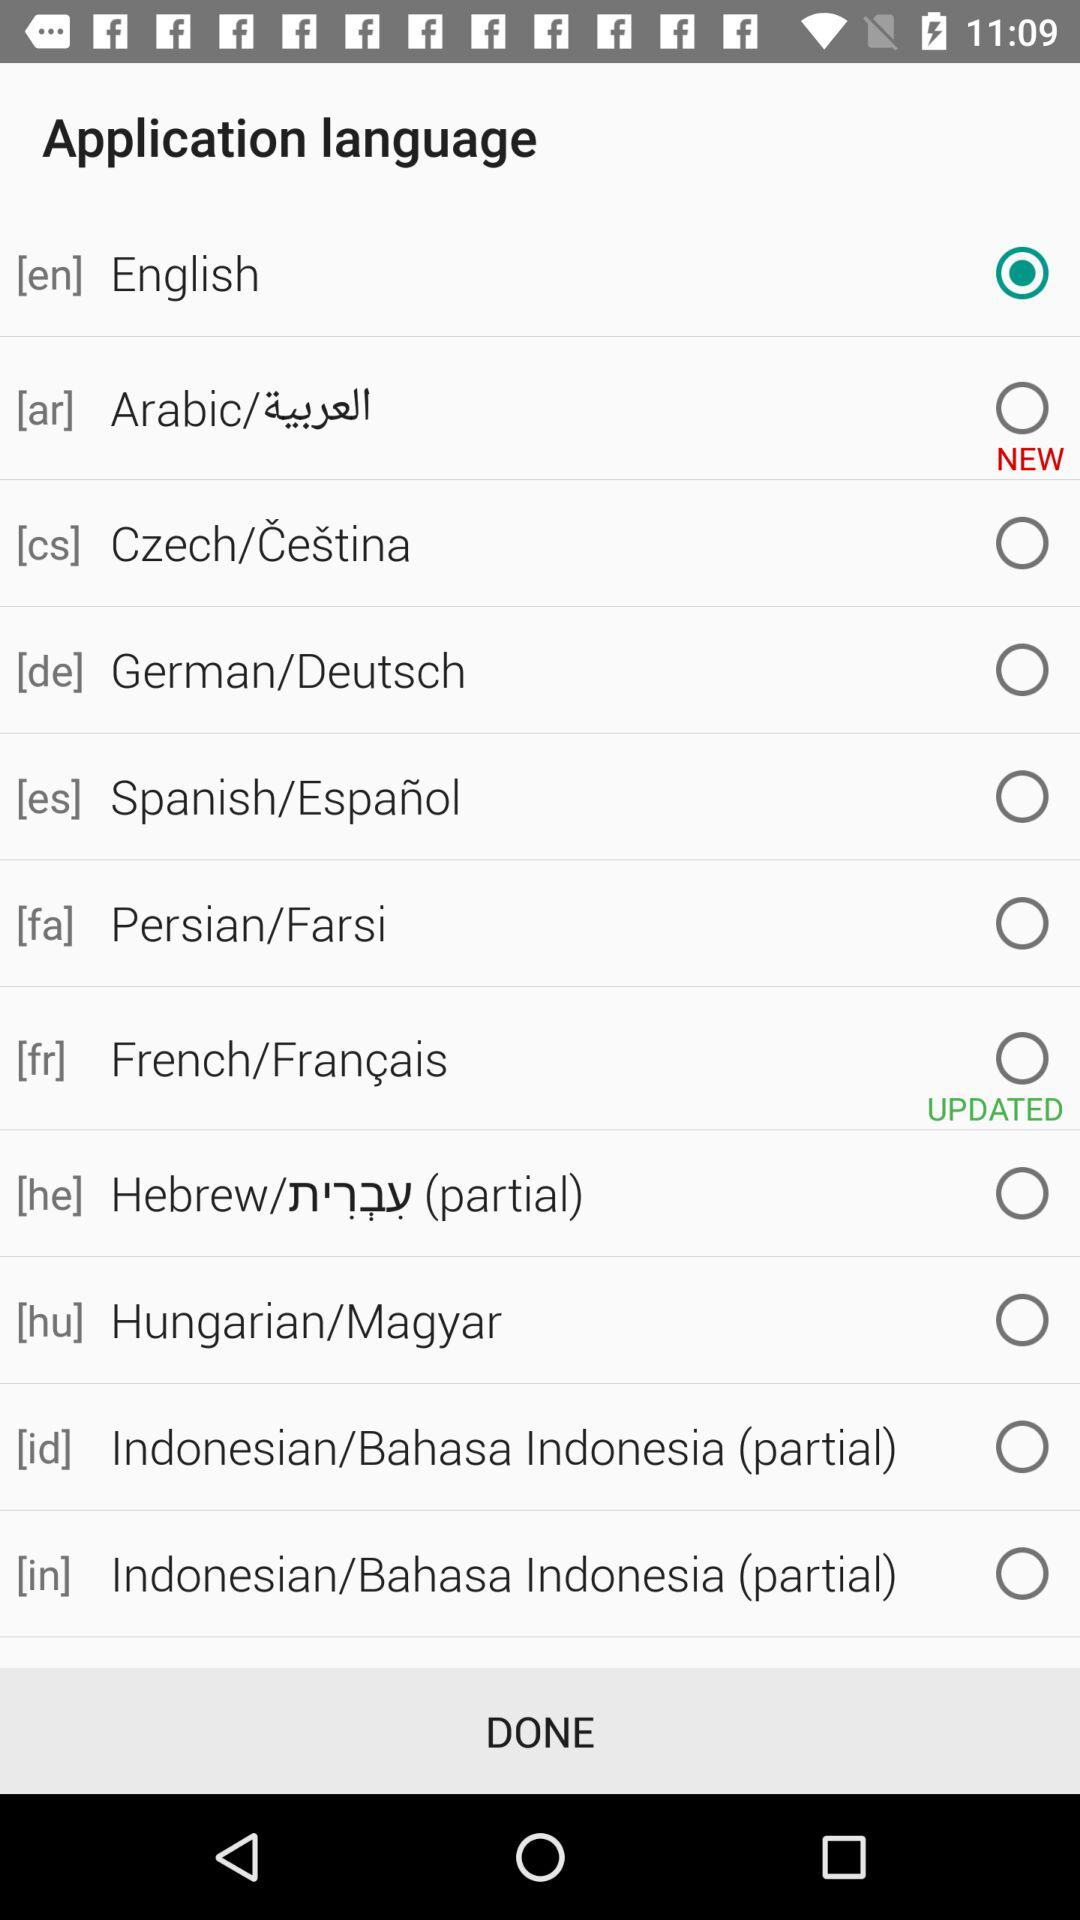What is the version of this application?
When the provided information is insufficient, respond with <no answer>. <no answer> 